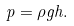Convert formula to latex. <formula><loc_0><loc_0><loc_500><loc_500>p = \rho g h .</formula> 